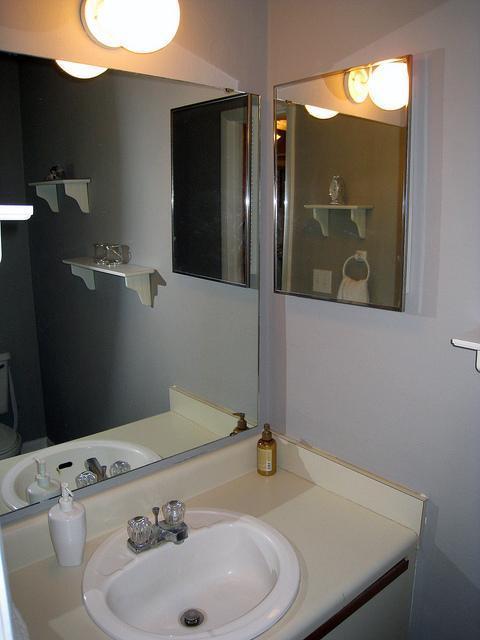How many mirrors are in the room?
Give a very brief answer. 2. 